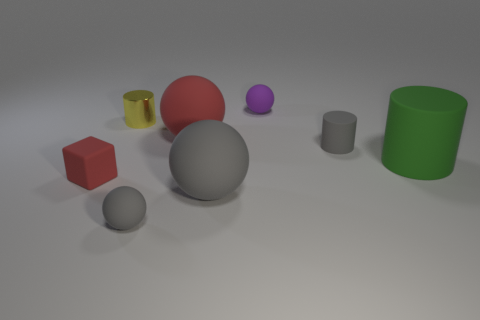Subtract all gray spheres. Subtract all red blocks. How many spheres are left? 2 Add 1 large green rubber cylinders. How many objects exist? 9 Subtract all cylinders. How many objects are left? 5 Subtract all large red metallic cubes. Subtract all small yellow objects. How many objects are left? 7 Add 7 large things. How many large things are left? 10 Add 5 small gray matte blocks. How many small gray matte blocks exist? 5 Subtract 0 purple cylinders. How many objects are left? 8 